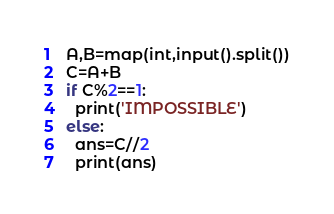Convert code to text. <code><loc_0><loc_0><loc_500><loc_500><_Python_>A,B=map(int,input().split())
C=A+B
if C%2==1:
  print('IMPOSSIBLE')
else:
  ans=C//2
  print(ans)
</code> 